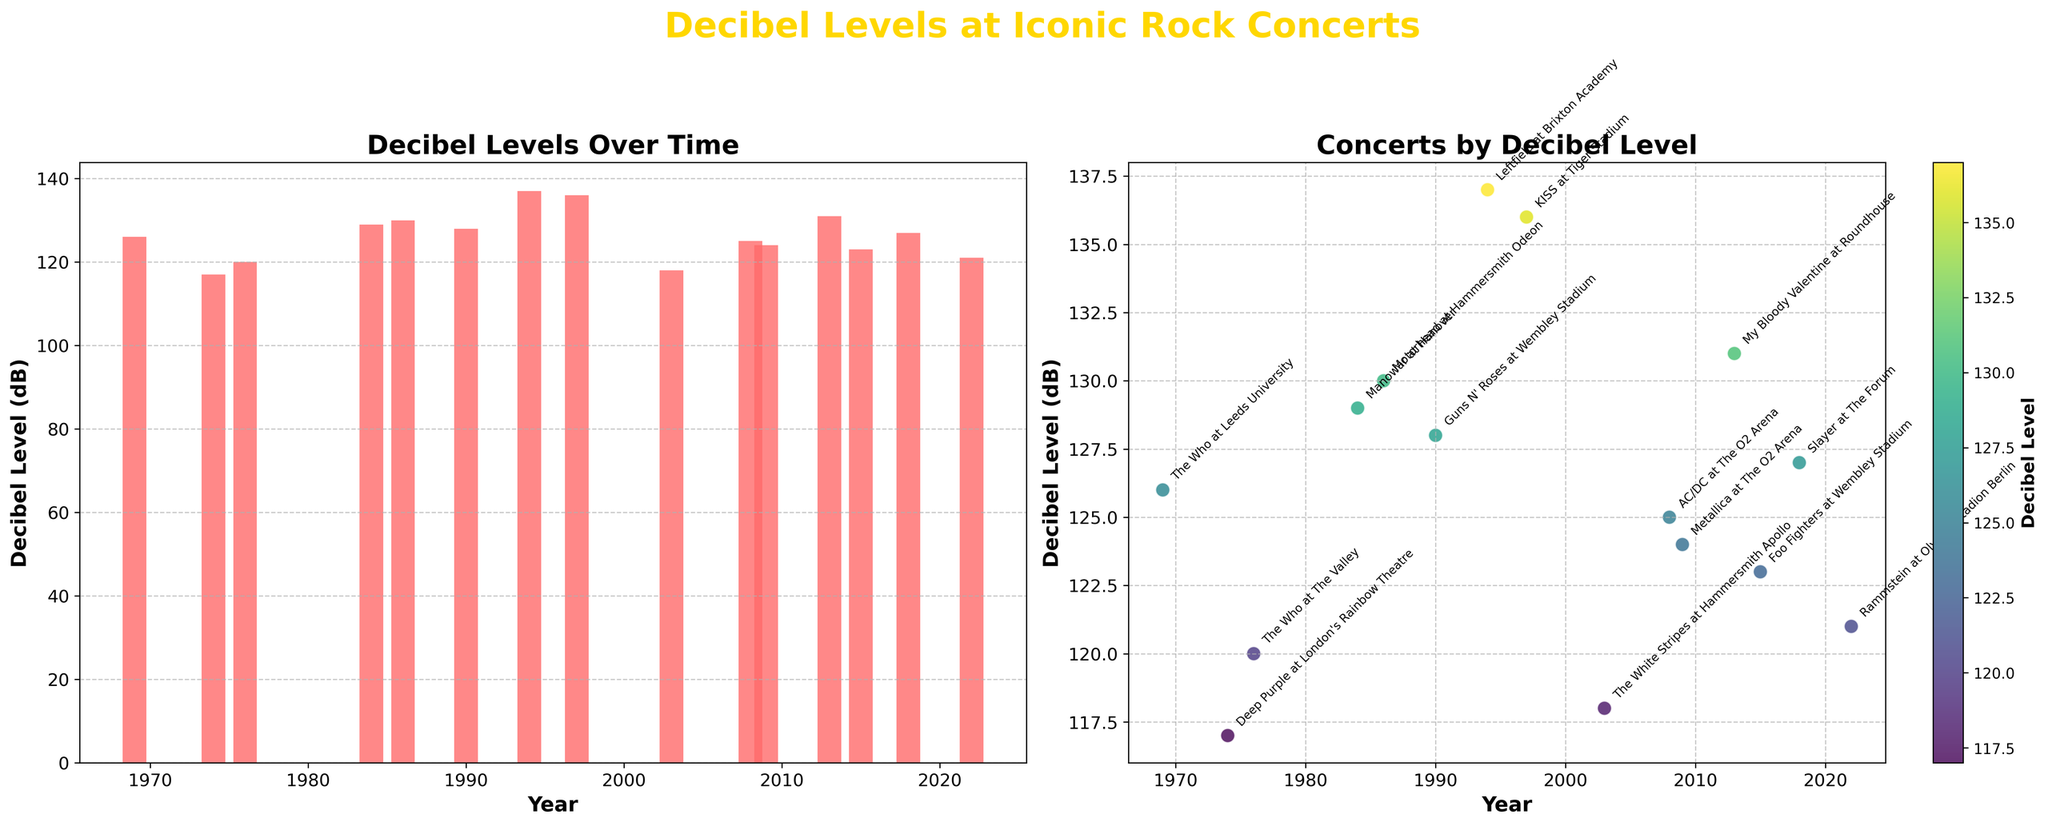What's the highest decibel level recorded in the plotted concerts? In the scatter plot and the bar plot, the highest dot and bar reach just above 135 dB. The concert with the highest decibel level is Leftfield at Brixton Academy in 1994.
Answer: 137 dB Which concert had a higher decibel level, KISS at Tiger Stadium in 1997 or Foo Fighters at Wembley Stadium in 2015? Comparing the decibel levels of the two concerts, KISS in 1997 had 136 dB, and Foo Fighters in 2015 had 123 dB. Thus, KISS had a higher decibel level.
Answer: KISS at Tiger Stadium What is the average decibel level of the concerts in the 2000s? The concerts in the 2000s are The White Stripes in 2003 (118 dB), AC/DC in 2008 (125 dB), and Metallica in 2009 (124 dB). The average is (118 + 125 + 124) / 3 = 122.33 dB.
Answer: 122.33 dB Which decade had the most consistently high decibel levels? By observing the scatter plot, the 2010s had high and consistent decibel levels. Slayer in 2018 had 127 dB, and My Bloody Valentine in 2013 had 131 dB.
Answer: 2010s Are there any concerts with the same decibel level? The scatter plot shows two colored dots at almost the same height for Guns N' Roses in 1990 (128 dB) and KISS in 1997 (136 dB), so no concerts share the exact same level.
Answer: No What is the difference in decibel level between The Who at Leeds University in 1969 and The Who at The Valley in 1976? The Who at Leeds University reached 126 dB in 1969, compared to 120 dB at The Valley in 1976. The difference is 126 - 120 = 6 dB.
Answer: 6 dB Which year saw the loudest concert? From the scatter plot, the highest point is 1994 for Leftfield at Brixton Academy, 137 dB.
Answer: 1994 How does the decibel level of Rammstein's concert in 2022 compare to Motorhead's in 1986? Rammstein in 2022 reached 121 dB, while Motorhead in 1986 reached 130 dB, so Motorhead's concert was louder by 9 dB.
Answer: Motorhead's was louder What is the general trend of decibel levels from 1969 to 2022? Observing the bar plot, there is a noticeable increase in levels over time, peaking around the mid-1990s before seeing a slight decrease but remaining high in the 2000s and 2010s.
Answer: Increasing trend Between 1980 and 2000, which concert had the lowest decibel level? In the scatter plot, the concerts between 1980 and 2000 include Manowar’s in 1984, Motorhead’s in 1986, and Guns N' Roses’ in 1990. The White Stripes in 2003 had a lower level. The lowest of these is The White Stripes (118 dB).
Answer: The White Stripes 